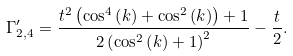<formula> <loc_0><loc_0><loc_500><loc_500>\Gamma _ { 2 , 4 } ^ { \prime } = \frac { t ^ { 2 } \left ( \cos ^ { 4 } \left ( k \right ) + \cos ^ { 2 } \left ( k \right ) \right ) + 1 } { 2 \left ( \cos ^ { 2 } \left ( k \right ) + 1 \right ) ^ { 2 } } - \frac { t } { 2 } .</formula> 